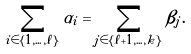Convert formula to latex. <formula><loc_0><loc_0><loc_500><loc_500>\sum _ { i \in \{ 1 , \dots , \ell \} } \alpha _ { i } = \sum _ { j \in \{ \ell + 1 , \dots , k \} } \beta _ { j } .</formula> 